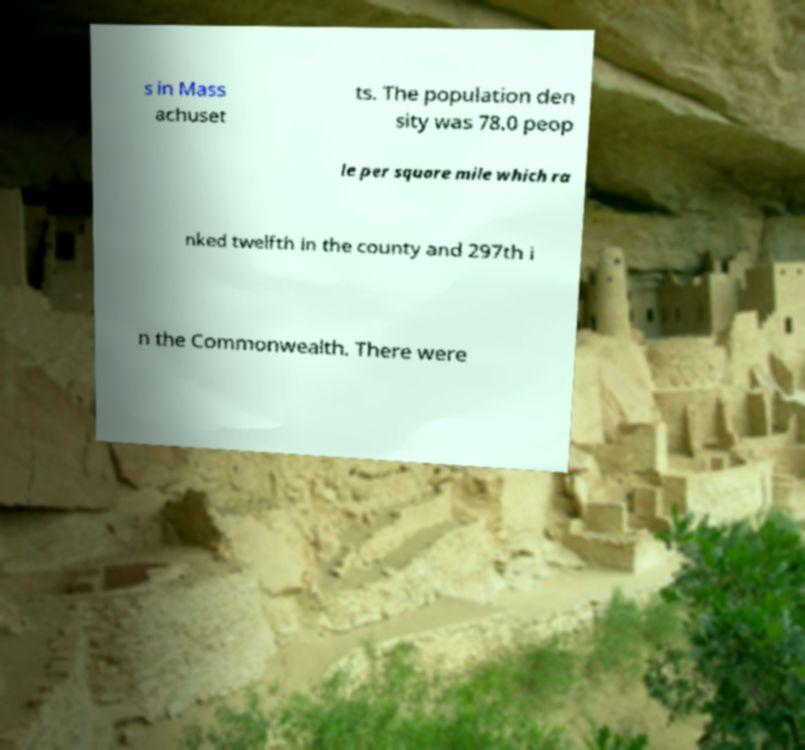I need the written content from this picture converted into text. Can you do that? s in Mass achuset ts. The population den sity was 78.0 peop le per square mile which ra nked twelfth in the county and 297th i n the Commonwealth. There were 